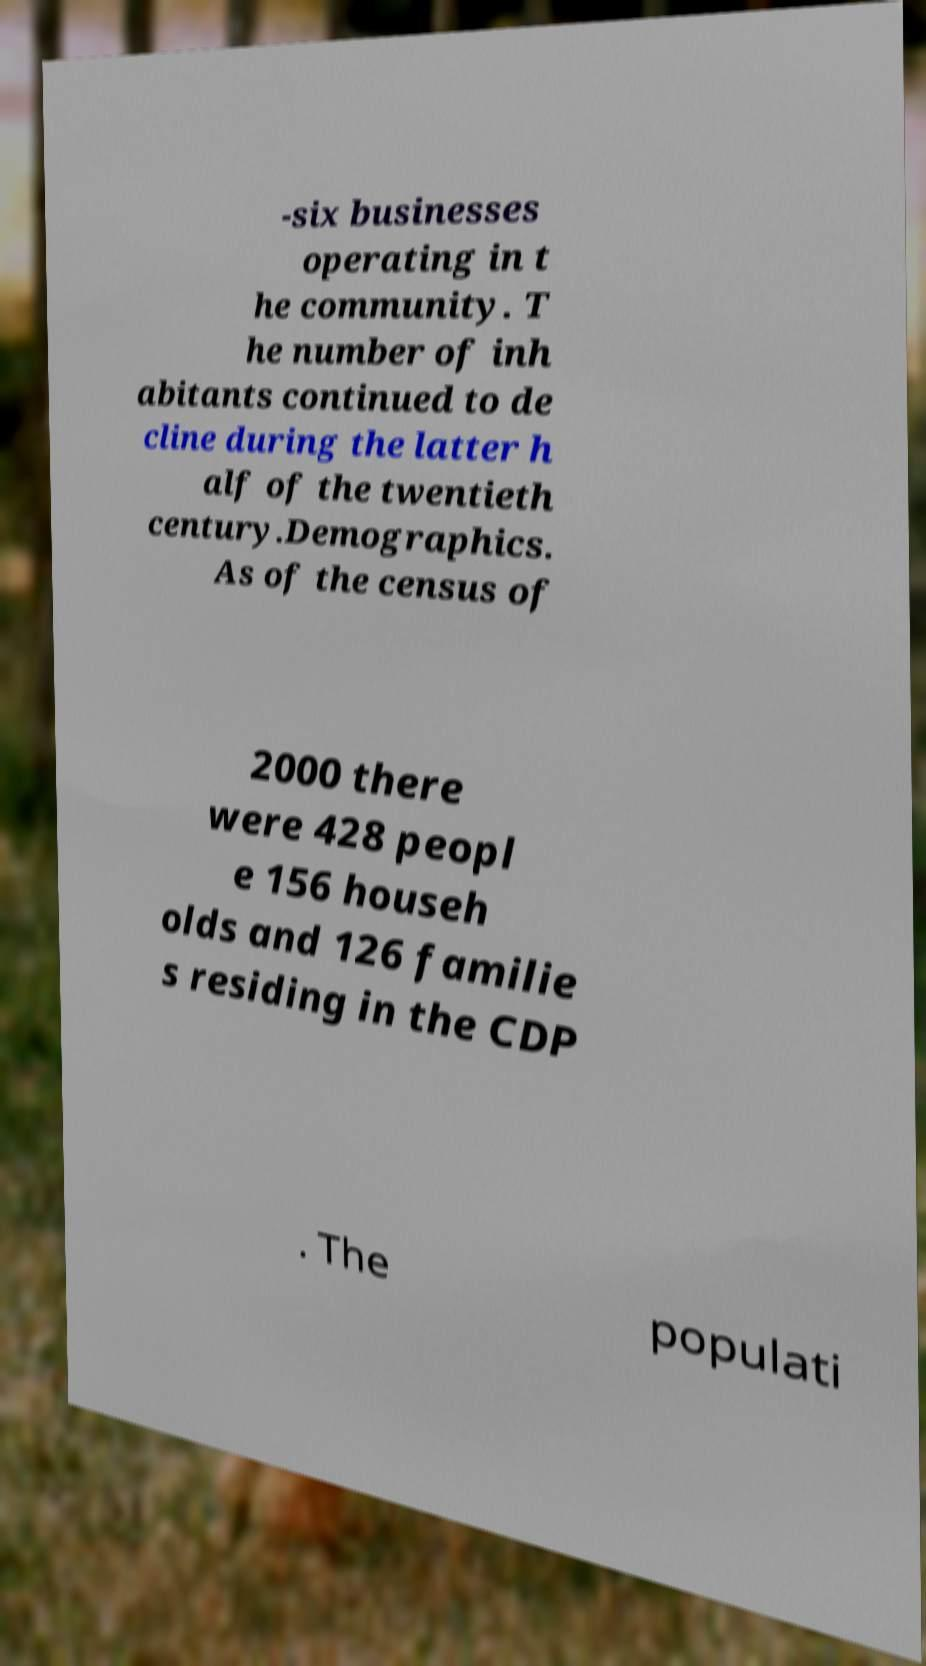Please identify and transcribe the text found in this image. -six businesses operating in t he community. T he number of inh abitants continued to de cline during the latter h alf of the twentieth century.Demographics. As of the census of 2000 there were 428 peopl e 156 househ olds and 126 familie s residing in the CDP . The populati 